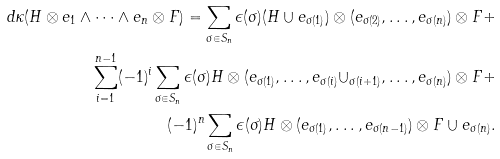<formula> <loc_0><loc_0><loc_500><loc_500>d \kappa ( H \otimes e _ { 1 } \wedge \dots \wedge e _ { n } \otimes F ) = \sum _ { \sigma \in S _ { n } } \epsilon ( \sigma ) ( H \cup e _ { \sigma ( 1 ) } ) \otimes ( e _ { \sigma ( 2 ) } , \dots , e _ { \sigma ( n ) } ) \otimes F + \\ \sum _ { i = 1 } ^ { n - 1 } ( - 1 ) ^ { i } \sum _ { \sigma \in S _ { n } } \epsilon ( \sigma ) H \otimes ( e _ { \sigma ( 1 ) } , \dots , e _ { \sigma ( i ) } \cup _ { \sigma ( i + 1 ) } , \dots , e _ { \sigma ( n ) } ) \otimes F + \\ ( - 1 ) ^ { n } \sum _ { \sigma \in S _ { n } } \epsilon ( \sigma ) H \otimes ( e _ { \sigma ( 1 ) } , \dots , e _ { \sigma ( n - 1 ) } ) \otimes F \cup e _ { \sigma ( n ) } .</formula> 